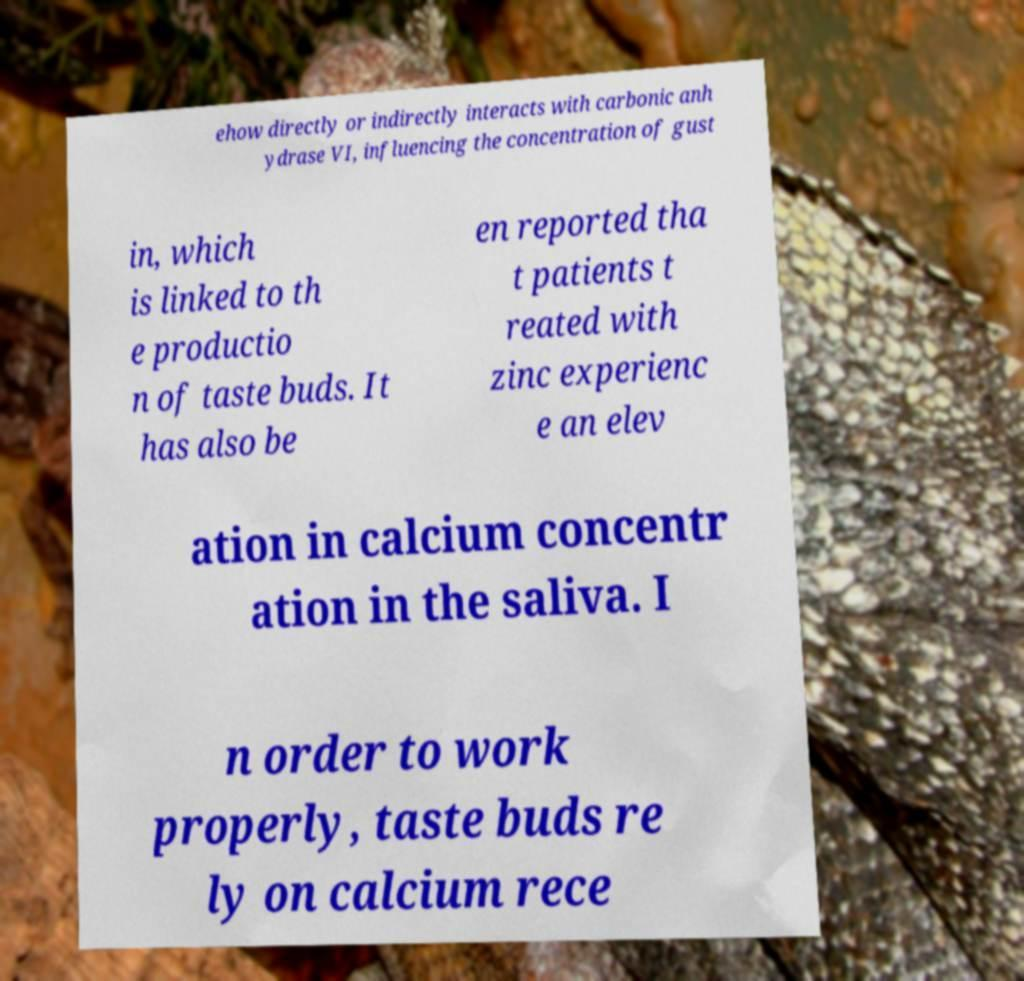There's text embedded in this image that I need extracted. Can you transcribe it verbatim? ehow directly or indirectly interacts with carbonic anh ydrase VI, influencing the concentration of gust in, which is linked to th e productio n of taste buds. It has also be en reported tha t patients t reated with zinc experienc e an elev ation in calcium concentr ation in the saliva. I n order to work properly, taste buds re ly on calcium rece 